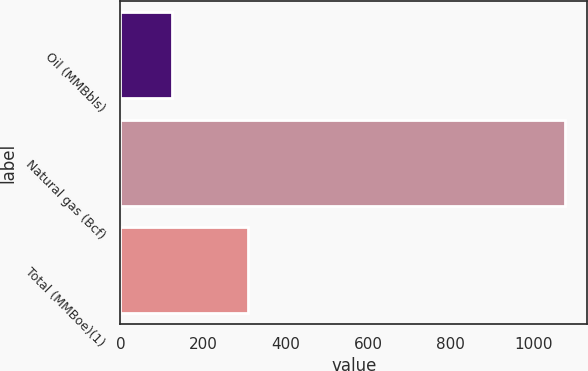Convert chart to OTSL. <chart><loc_0><loc_0><loc_500><loc_500><bar_chart><fcel>Oil (MMBbls)<fcel>Natural gas (Bcf)<fcel>Total (MMBoe)(1)<nl><fcel>126<fcel>1077<fcel>308<nl></chart> 